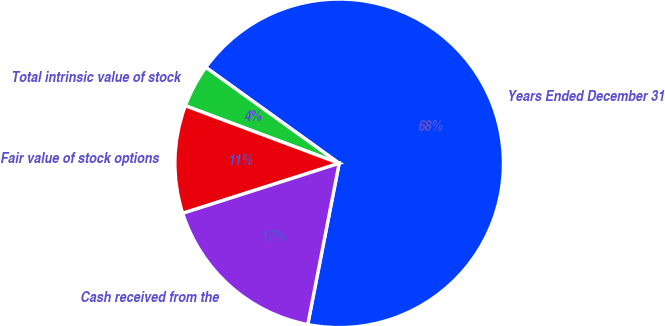Convert chart. <chart><loc_0><loc_0><loc_500><loc_500><pie_chart><fcel>Years Ended December 31<fcel>Total intrinsic value of stock<fcel>Fair value of stock options<fcel>Cash received from the<nl><fcel>68.13%<fcel>4.23%<fcel>10.62%<fcel>17.01%<nl></chart> 